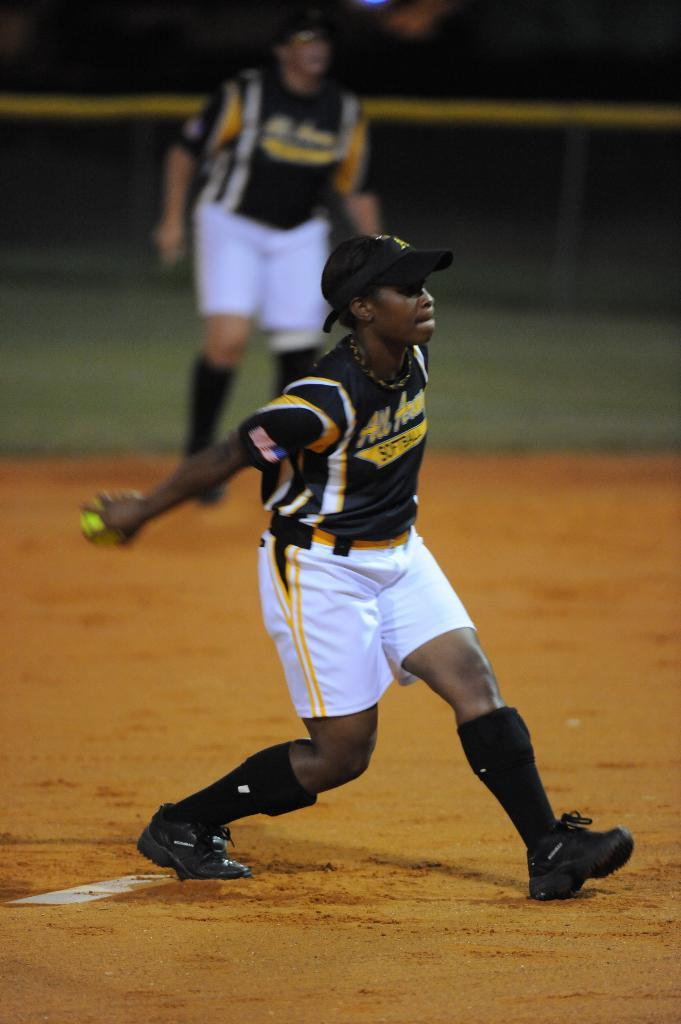<image>
Present a compact description of the photo's key features. A pitcher gets ready to pitch while wearing a softball jersey. 